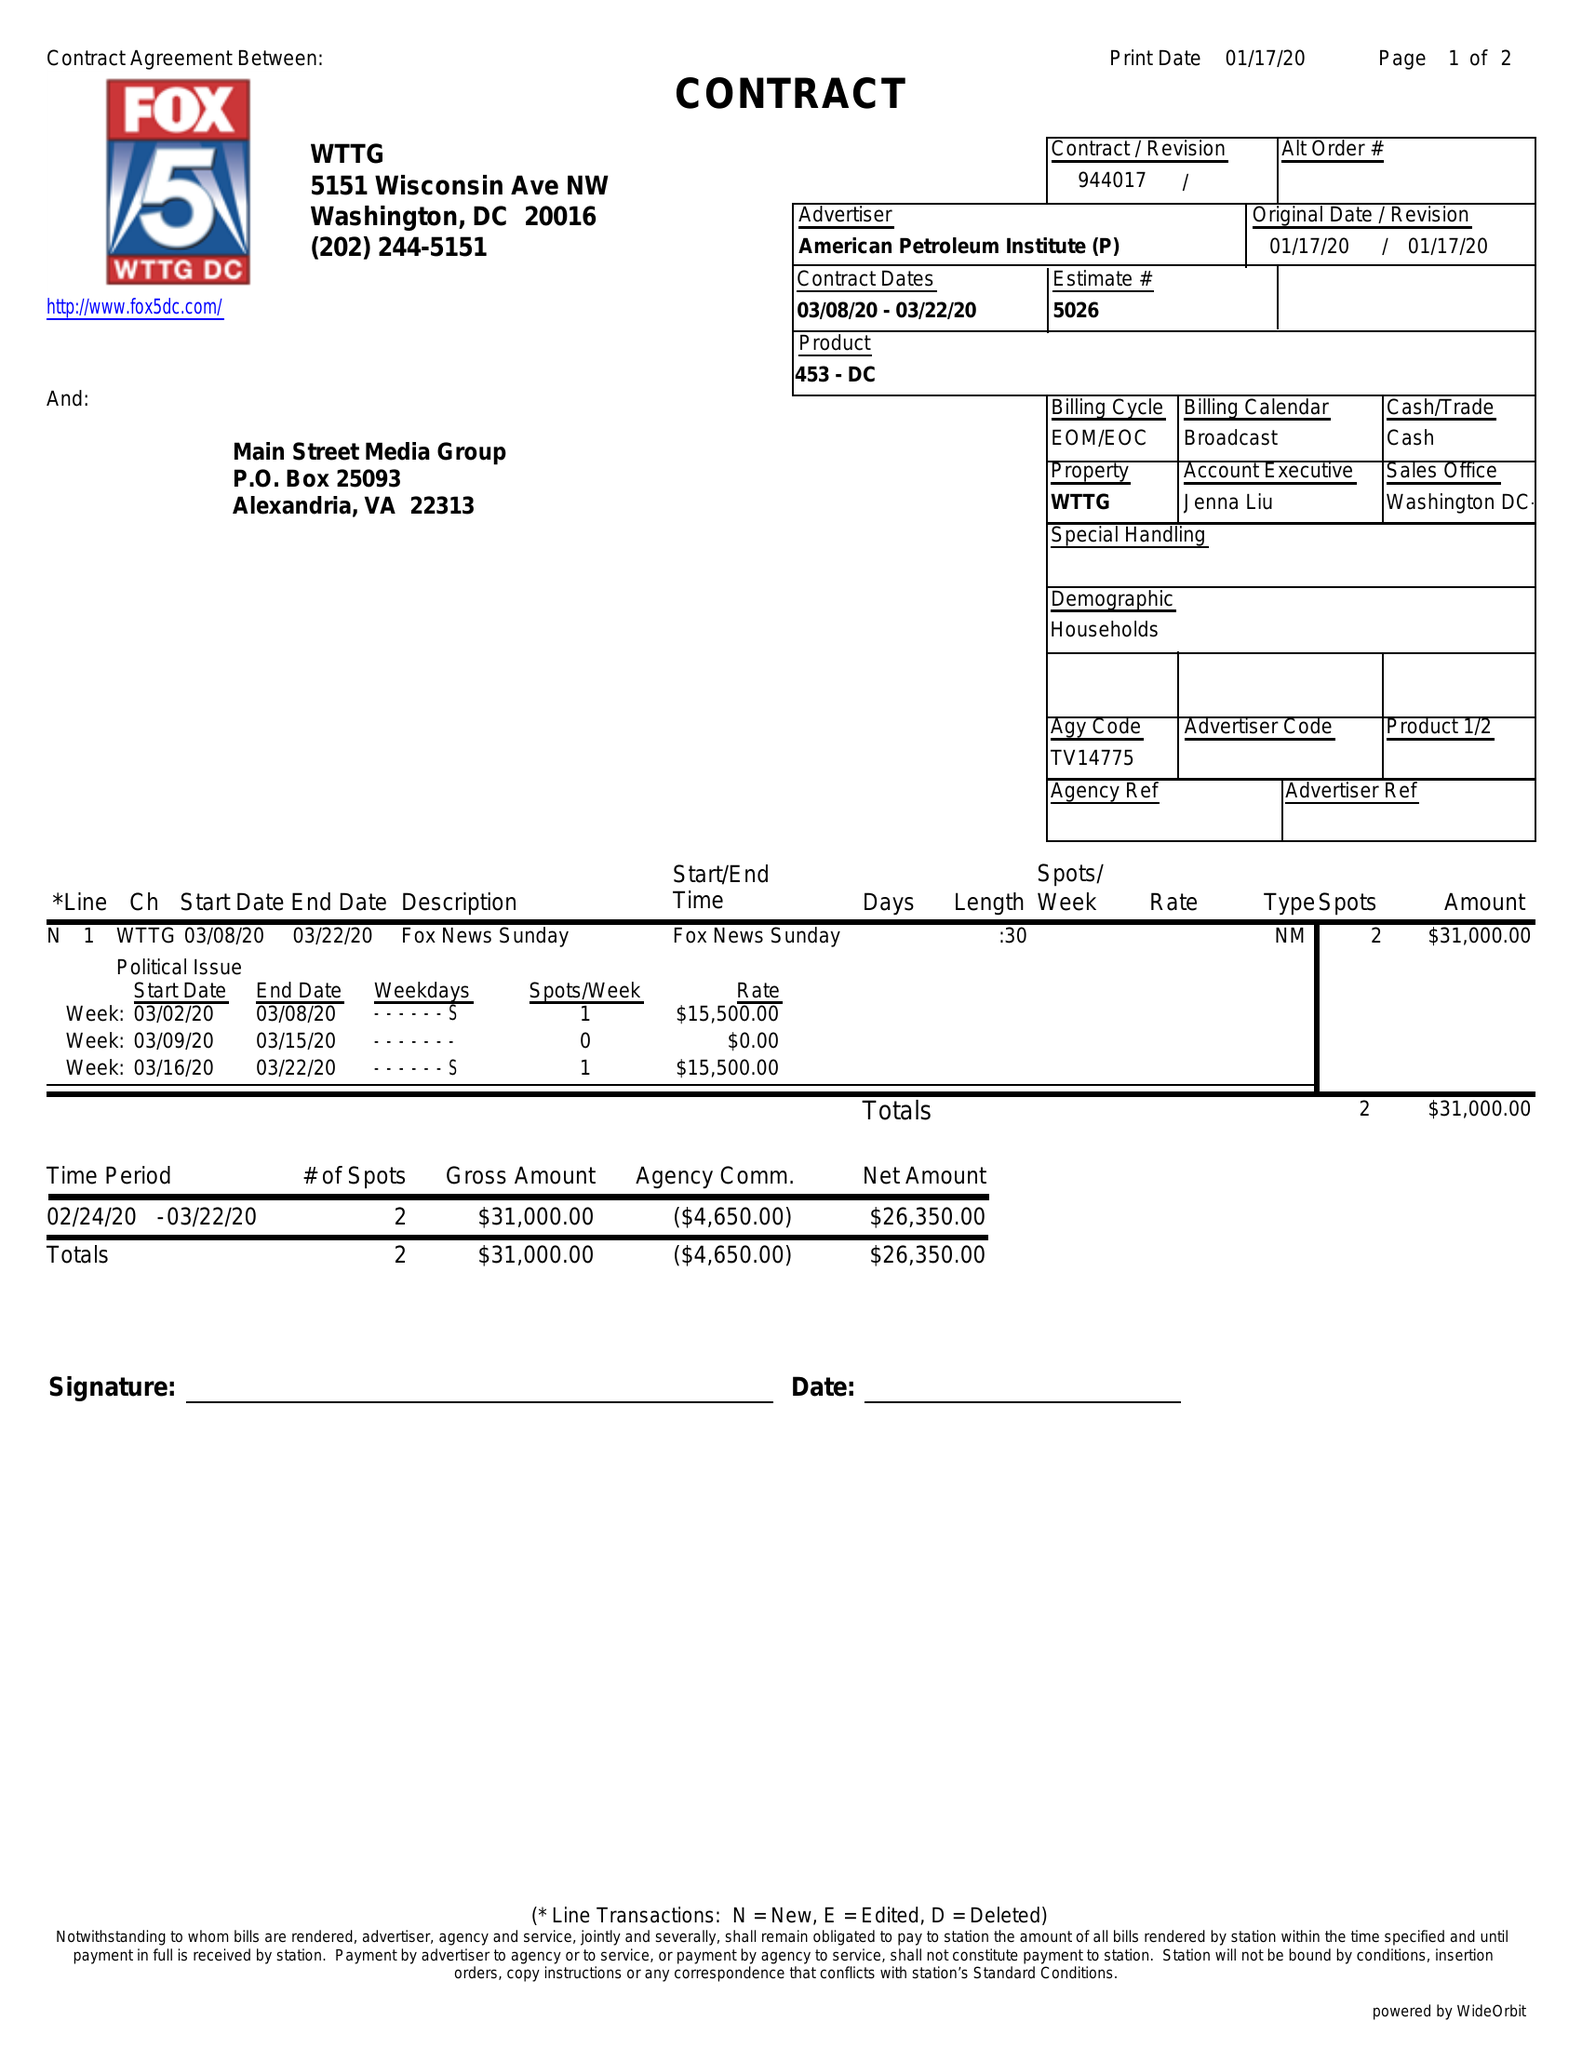What is the value for the gross_amount?
Answer the question using a single word or phrase. 31000.00 